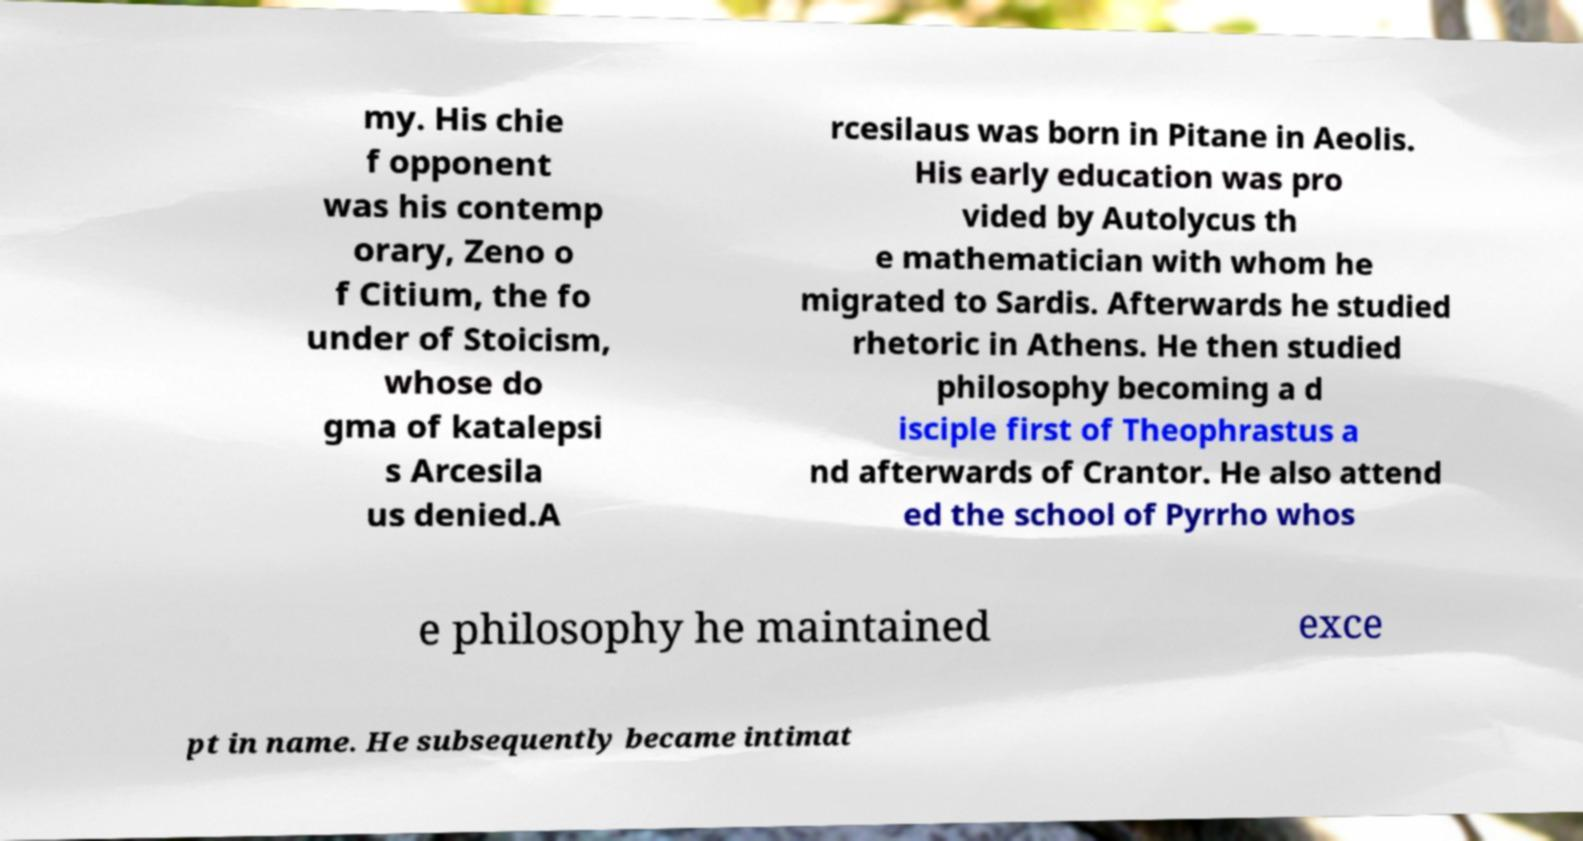Can you accurately transcribe the text from the provided image for me? my. His chie f opponent was his contemp orary, Zeno o f Citium, the fo under of Stoicism, whose do gma of katalepsi s Arcesila us denied.A rcesilaus was born in Pitane in Aeolis. His early education was pro vided by Autolycus th e mathematician with whom he migrated to Sardis. Afterwards he studied rhetoric in Athens. He then studied philosophy becoming a d isciple first of Theophrastus a nd afterwards of Crantor. He also attend ed the school of Pyrrho whos e philosophy he maintained exce pt in name. He subsequently became intimat 